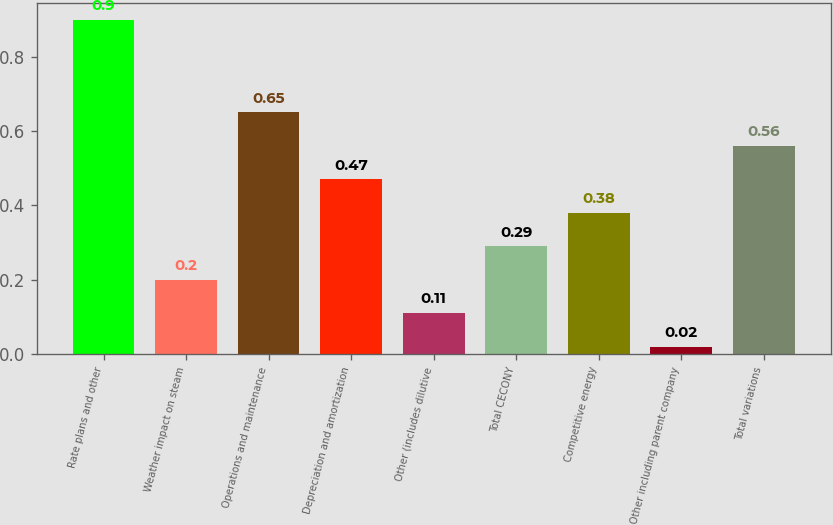Convert chart to OTSL. <chart><loc_0><loc_0><loc_500><loc_500><bar_chart><fcel>Rate plans and other<fcel>Weather impact on steam<fcel>Operations and maintenance<fcel>Depreciation and amortization<fcel>Other (includes dilutive<fcel>Total CECONY<fcel>Competitive energy<fcel>Other including parent company<fcel>Total variations<nl><fcel>0.9<fcel>0.2<fcel>0.65<fcel>0.47<fcel>0.11<fcel>0.29<fcel>0.38<fcel>0.02<fcel>0.56<nl></chart> 